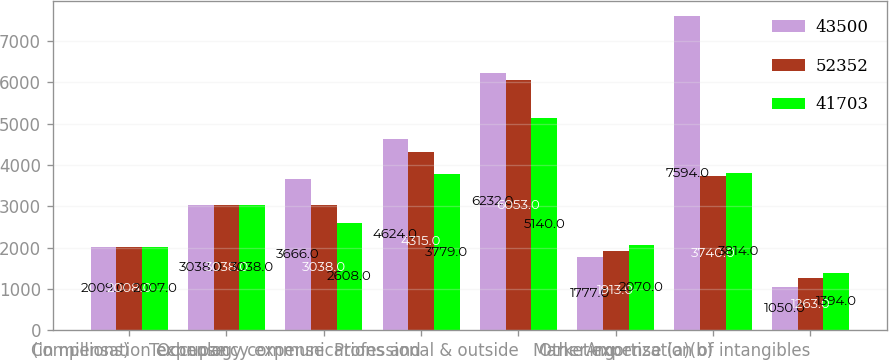<chart> <loc_0><loc_0><loc_500><loc_500><stacked_bar_chart><ecel><fcel>(in millions)<fcel>Compensation expense<fcel>Occupancy expense<fcel>Technology communications and<fcel>Professional & outside<fcel>Marketing<fcel>Other expense (a)(b)<fcel>Amortization of intangibles<nl><fcel>43500<fcel>2009<fcel>3038<fcel>3666<fcel>4624<fcel>6232<fcel>1777<fcel>7594<fcel>1050<nl><fcel>52352<fcel>2008<fcel>3038<fcel>3038<fcel>4315<fcel>6053<fcel>1913<fcel>3740<fcel>1263<nl><fcel>41703<fcel>2007<fcel>3038<fcel>2608<fcel>3779<fcel>5140<fcel>2070<fcel>3814<fcel>1394<nl></chart> 